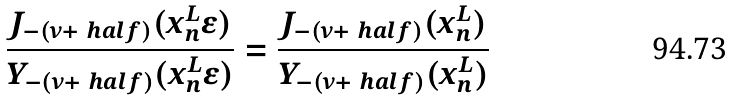Convert formula to latex. <formula><loc_0><loc_0><loc_500><loc_500>\frac { J _ { - ( \nu + \ h a l f ) } ( x _ { n } ^ { L } \epsilon ) } { Y _ { - ( \nu + \ h a l f ) } ( x _ { n } ^ { L } \epsilon ) } = \frac { J _ { - ( \nu + \ h a l f ) } ( x _ { n } ^ { L } ) } { Y _ { - ( \nu + \ h a l f ) } ( x _ { n } ^ { L } ) }</formula> 